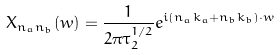Convert formula to latex. <formula><loc_0><loc_0><loc_500><loc_500>X _ { n _ { a } n _ { b } } ( w ) = \frac { 1 } { 2 \pi \tau _ { 2 } ^ { 1 / 2 } } e ^ { i ( n _ { a } k _ { a } + n _ { b } k _ { b } ) \cdot w }</formula> 